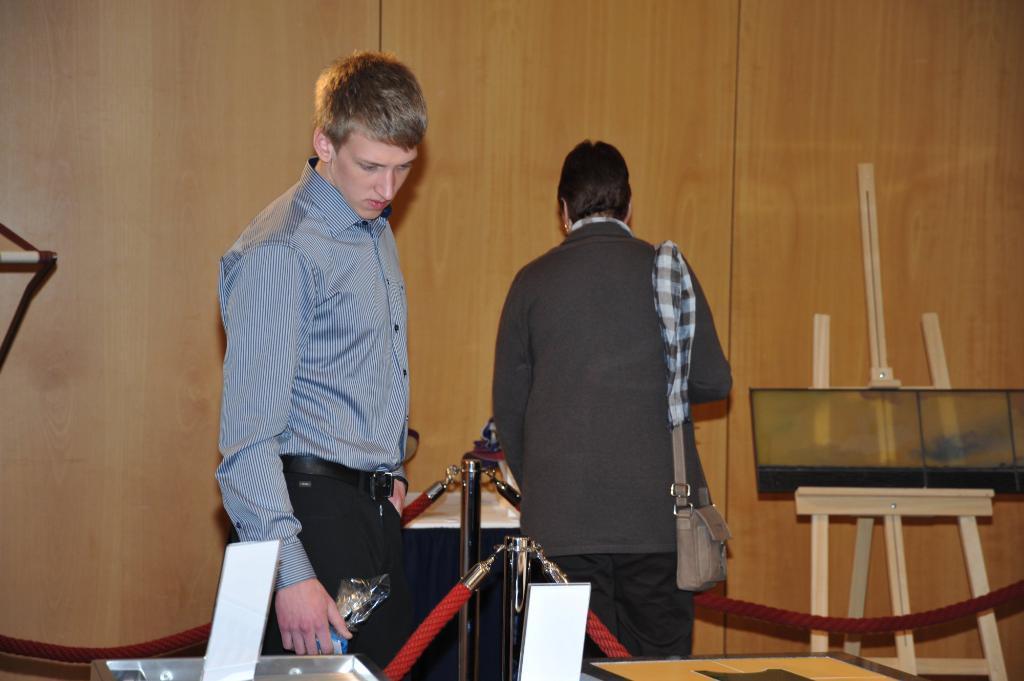In one or two sentences, can you explain what this image depicts? In this image I can see a person wearing shirt, black pant is standing and another person wearing jacket, bag and black pant is standing. I can see few rows which are red in color, few white colored objects, a cream colored stand and the brown colored wall. 